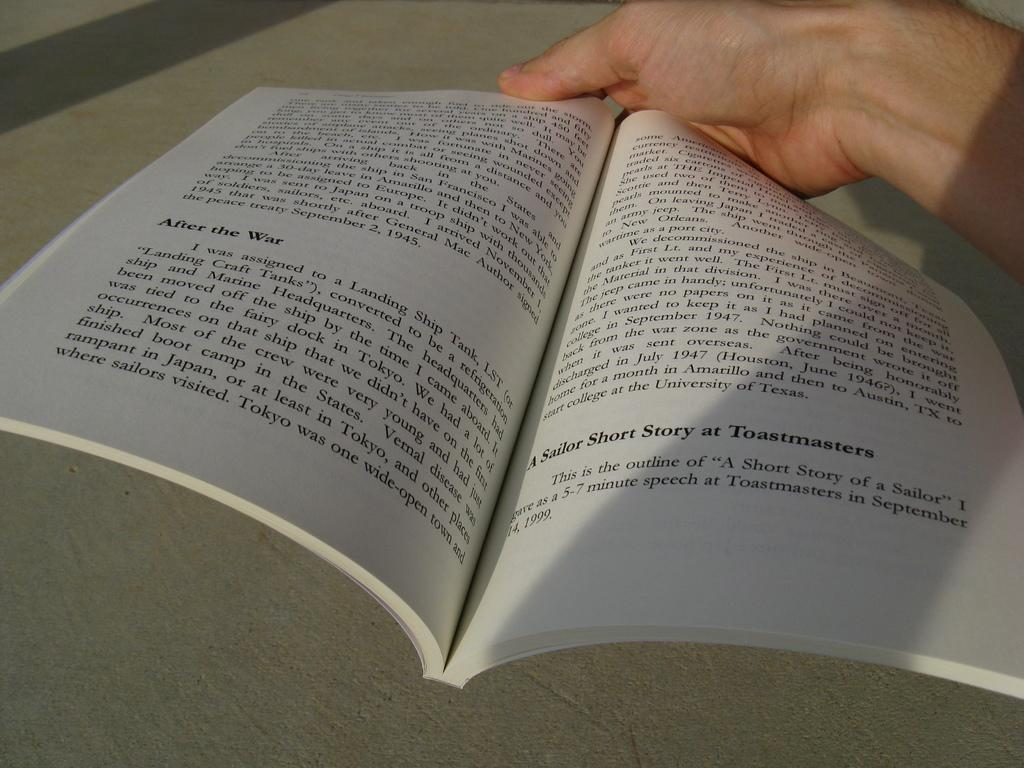<image>
Provide a brief description of the given image. A book is open, the page on the left has a heading of ,"After the War." 